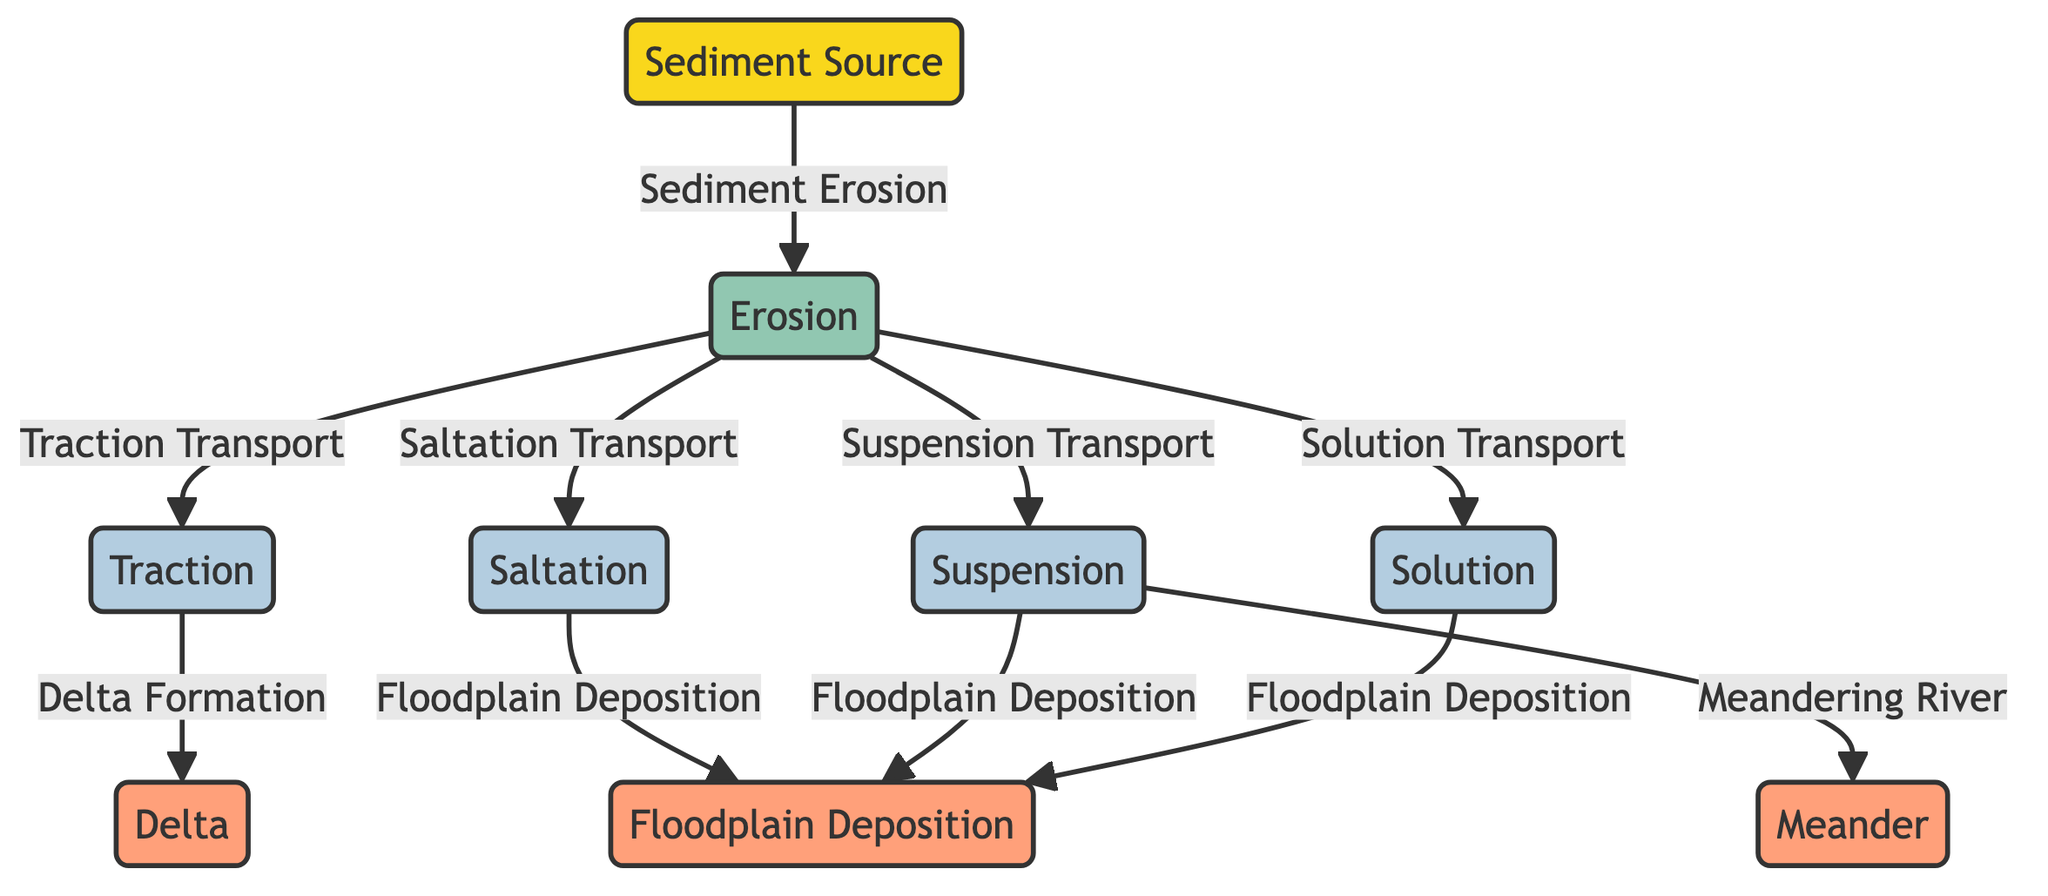What is the initial point of sediment in the diagram? The diagram depicts "Sediment Source" as the initial node, indicating where sediment originates before undergoing various processes.
Answer: Sediment Source How many transport processes are shown in the diagram? The diagram includes four distinct transport processes: Traction, Saltation, Suspension, and Solution, which are essential methods for moving sediments.
Answer: 4 What type of deposition occurs at the delta? The diagram specifically indicates that Delta Formation is a result of Traction Transport, emphasizing how materials accumulate in a delta.
Answer: Delta Formation Which transport process leads to meandering rivers? According to the diagram, Suspension is the transport process linked with the formation of meandering rivers, highlighting its role in shaping river morphology.
Answer: Suspension What are the three types of deposition listed in the diagram? The diagram includes three types of deposition: Delta, Floodplain Deposition, and Meander, showcasing different sediment accumulation areas within river systems.
Answer: Delta, Floodplain Deposition, Meander How does erosion relate to floodplain deposition? The diagram shows multiple paths (Suspension, Saltation, and Solution) leading from Erosion to Floodplain Deposition, indicating that sediments transported from erosion can accumulate in floodplains in various ways.
Answer: Multiple paths from Erosion What is the ultimate depositional form called at the end of the sediment transport process? The diagram concludes with the term "Delta," representing a significant depositional feature that results from sediment transport and accumulation.
Answer: Delta Identify one process that occurs after erosion in the sediment transport sequence. After Erosion, the diagram presents Traction Transport as one of the next steps in the sediment transport sequence, indicating its role in moving sediments downstream.
Answer: Traction Transport Which node indicates a river’s primary sediment transport process? The diagram illustrates "Saltation" as a key transport process of sediments, indicating its importance in river sediment dynamics.
Answer: Saltation 